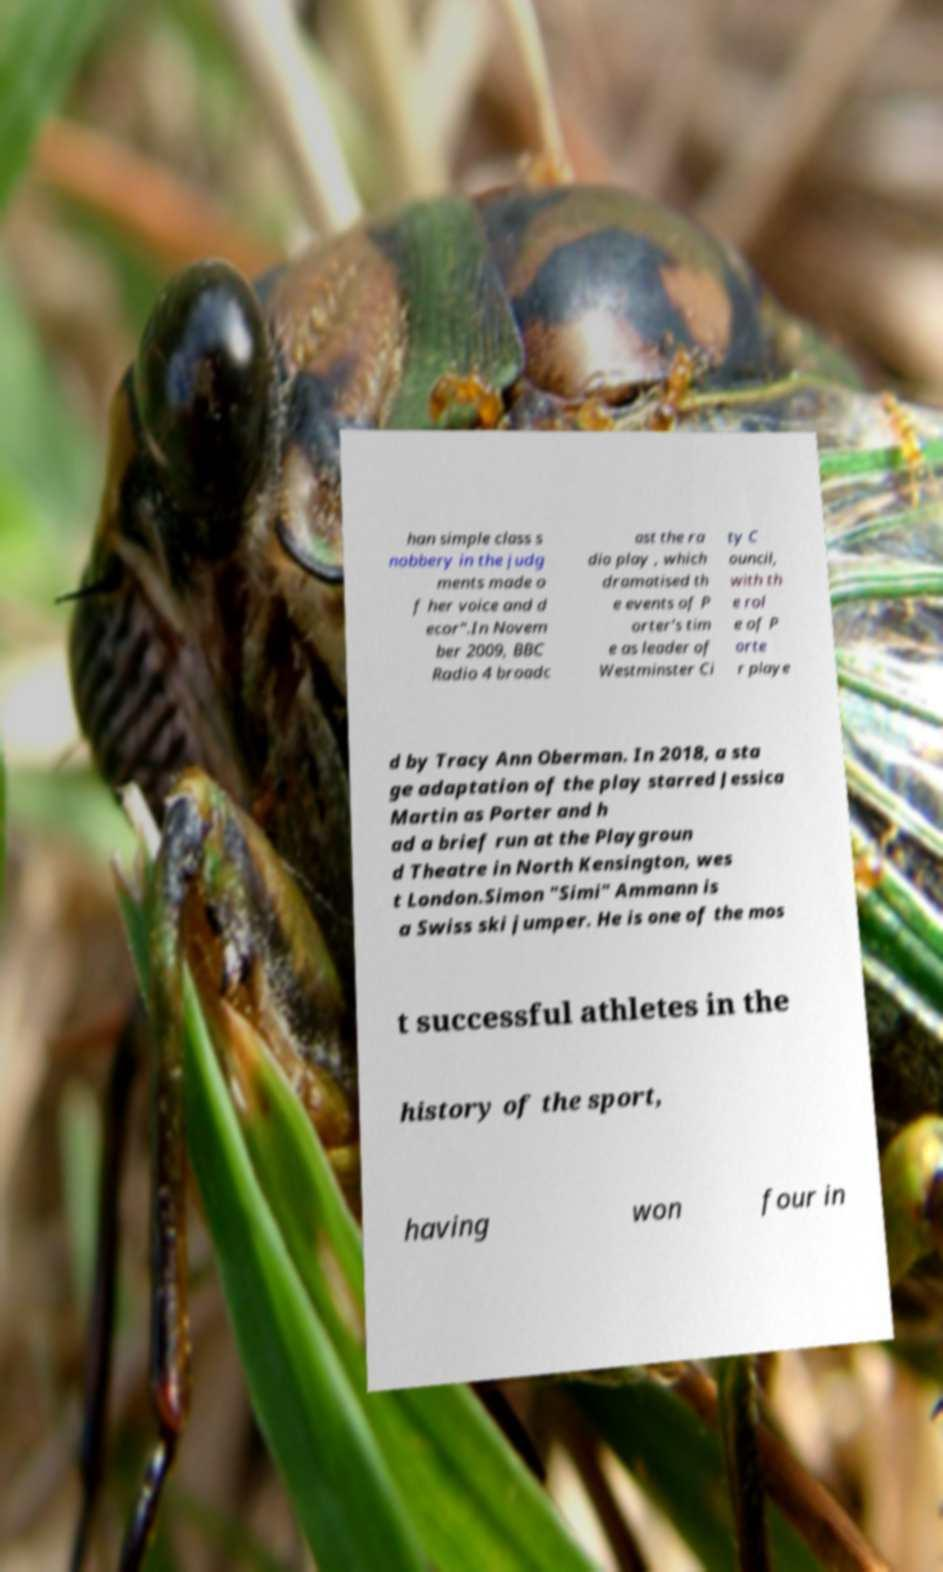Please read and relay the text visible in this image. What does it say? han simple class s nobbery in the judg ments made o f her voice and d ecor".In Novem ber 2009, BBC Radio 4 broadc ast the ra dio play , which dramatised th e events of P orter's tim e as leader of Westminster Ci ty C ouncil, with th e rol e of P orte r playe d by Tracy Ann Oberman. In 2018, a sta ge adaptation of the play starred Jessica Martin as Porter and h ad a brief run at the Playgroun d Theatre in North Kensington, wes t London.Simon "Simi" Ammann is a Swiss ski jumper. He is one of the mos t successful athletes in the history of the sport, having won four in 